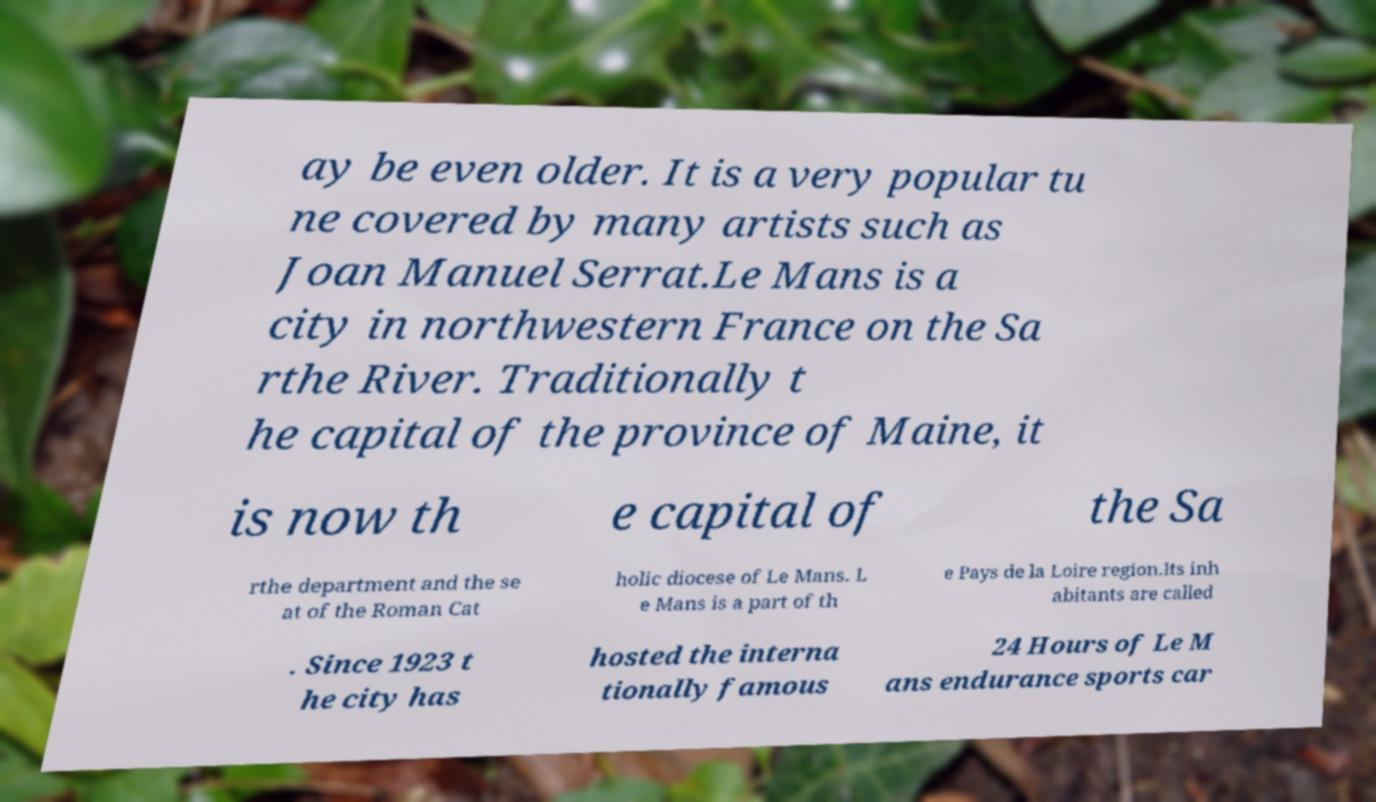Can you accurately transcribe the text from the provided image for me? ay be even older. It is a very popular tu ne covered by many artists such as Joan Manuel Serrat.Le Mans is a city in northwestern France on the Sa rthe River. Traditionally t he capital of the province of Maine, it is now th e capital of the Sa rthe department and the se at of the Roman Cat holic diocese of Le Mans. L e Mans is a part of th e Pays de la Loire region.Its inh abitants are called . Since 1923 t he city has hosted the interna tionally famous 24 Hours of Le M ans endurance sports car 